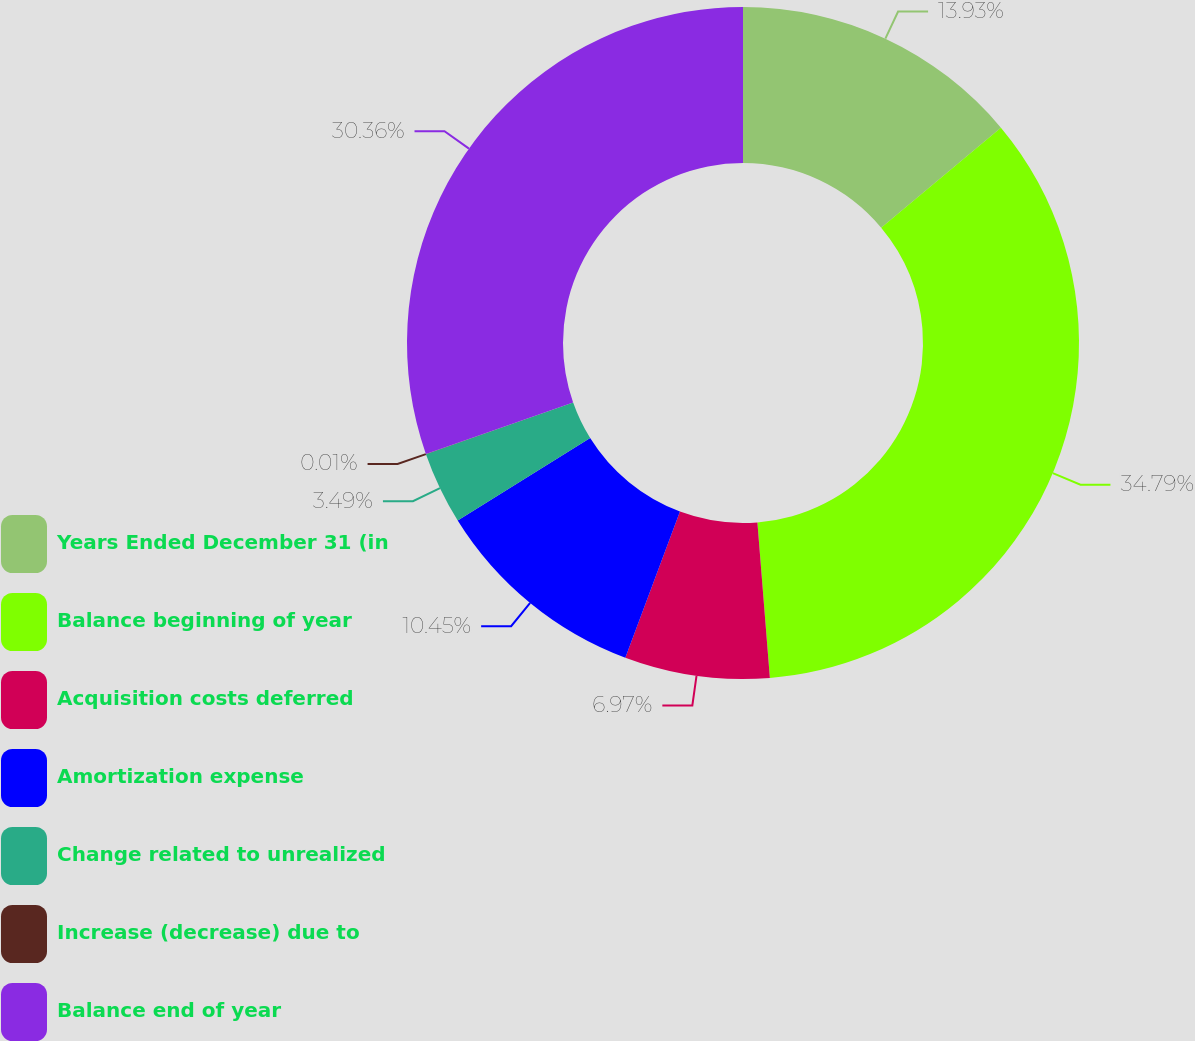Convert chart to OTSL. <chart><loc_0><loc_0><loc_500><loc_500><pie_chart><fcel>Years Ended December 31 (in<fcel>Balance beginning of year<fcel>Acquisition costs deferred<fcel>Amortization expense<fcel>Change related to unrealized<fcel>Increase (decrease) due to<fcel>Balance end of year<nl><fcel>13.93%<fcel>34.8%<fcel>6.97%<fcel>10.45%<fcel>3.49%<fcel>0.01%<fcel>30.36%<nl></chart> 